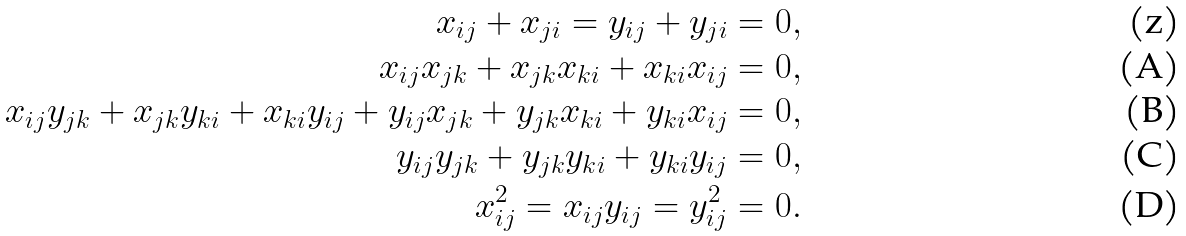<formula> <loc_0><loc_0><loc_500><loc_500>x _ { i j } + x _ { j i } = y _ { i j } + y _ { j i } = 0 , \\ x _ { i j } x _ { j k } + x _ { j k } x _ { k i } + x _ { k i } x _ { i j } = 0 , \\ x _ { i j } y _ { j k } + x _ { j k } y _ { k i } + x _ { k i } y _ { i j } + y _ { i j } x _ { j k } + y _ { j k } x _ { k i } + y _ { k i } x _ { i j } = 0 , \\ y _ { i j } y _ { j k } + y _ { j k } y _ { k i } + y _ { k i } y _ { i j } = 0 , \\ x _ { i j } ^ { 2 } = x _ { i j } y _ { i j } = y _ { i j } ^ { 2 } = 0 .</formula> 